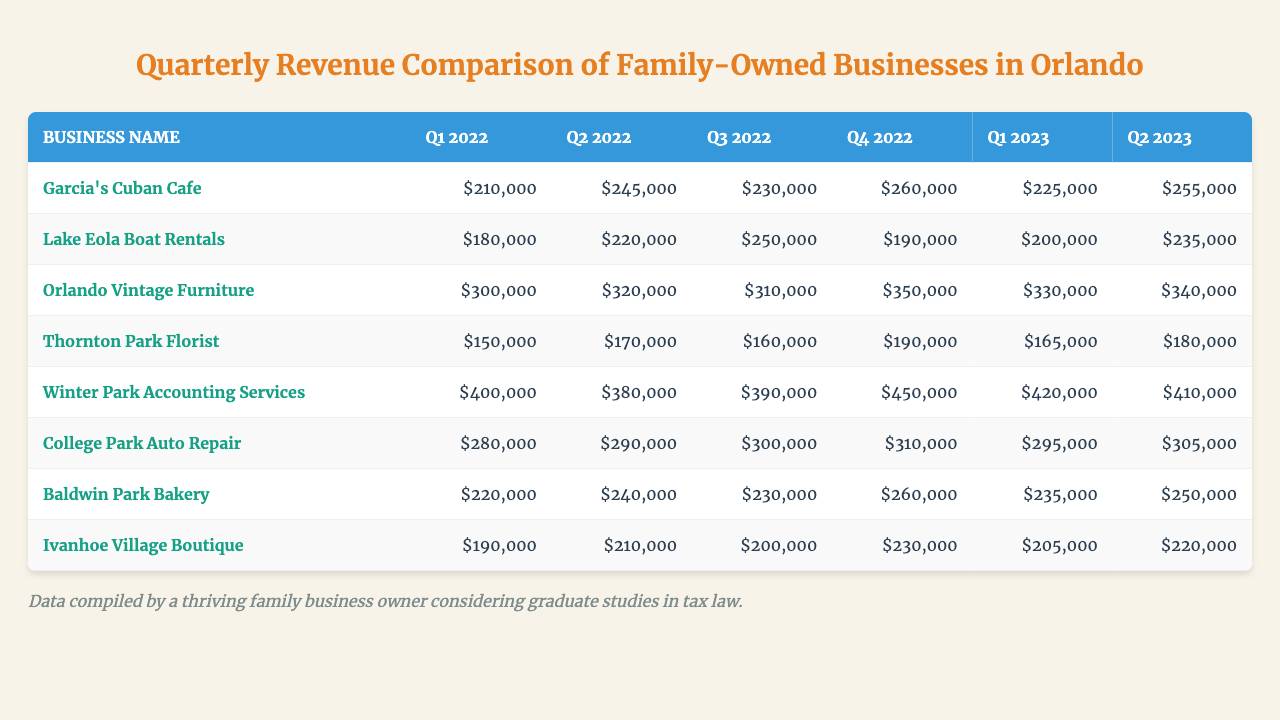What was the revenue of Orlando Vintage Furniture in Q3 2022? According to the table, the revenue for Orlando Vintage Furniture in Q3 2022 is listed directly; it shows $310,000.
Answer: $310,000 Which business had the highest revenue in Q4 2022? A look at the Q4 2022 column shows Winter Park Accounting Services with the highest revenue recorded at $450,000.
Answer: Winter Park Accounting Services What was the average revenue for Garcia's Cuban Cafe over the six quarters? Calculating the average revenue, we first sum the revenues (210000 + 245000 + 230000 + 260000 + 225000 + 255000 = 1425000) and divide by the number of quarters (6): 1425000 / 6 = 237500.
Answer: $237,500 Did College Park Auto Repair have a revenue decrease from Q1 2023 to Q2 2023? By comparing the revenues between Q1 2023 ($295,000) and Q2 2023 ($305,000) for College Park Auto Repair, we see an increase instead of a decrease.
Answer: No What is the total revenue of Baldwin Park Bakery across all quarters? By adding the revenues for Baldwin Park Bakery (220000 + 240000 + 230000 + 260000 + 235000 + 250000 = 1435000), we find the total revenue is $1,435,000.
Answer: $1,435,000 Which business showed the most significant increase in revenue from Q2 2022 to Q3 2022? Looking at the revenues of businesses in Q2 and Q3 2022, Lake Eola Boat Rentals went from $220,000 to $250,000, which is an increase of $30,000, while other increases are smaller, indicating that Lake Eola Boat Rentals had the most significant increase.
Answer: Lake Eola Boat Rentals What was the revenue of Ivanhoe Village Boutique in Q2 2023? The Q2 2023 revenue for Ivanhoe Village Boutique can be found in the table and is $210,000 as stated in that row.
Answer: $210,000 What is the percentage increase in revenue for Orlando Vintage Furniture from Q1 2022 to Q4 2022? The increase from Q1 2022 ($300,000) to Q4 2022 ($350,000) is calculated as follows: ((350000 - 300000) / 300000) * 100 = 16.67%.
Answer: 16.67% Which quarter did Thornton Park Florist have the lowest revenue? By checking the revenue for Thornton Park Florist in each quarter, we see that Q1 2022, with a revenue of $150,000, is the lowest among them.
Answer: Q1 2022 Did Winter Park Accounting Services consistently increase their revenue each quarter? Inspecting the revenues, they showed variations, specifically a decrease from Q2 2022 ($380,000) to Q3 2022 ($390,000). Thus, they did not consistently increase their revenue.
Answer: No What was the total revenue difference between Q1 2023 and Q2 2023 for the businesses combined? We sum the revenues for all businesses in Q1 2023 ($2,238,000) and Q2 2023 ($2,300,000), and calculate the difference: 2300000 - 2238000 = $62,000.
Answer: $62,000 